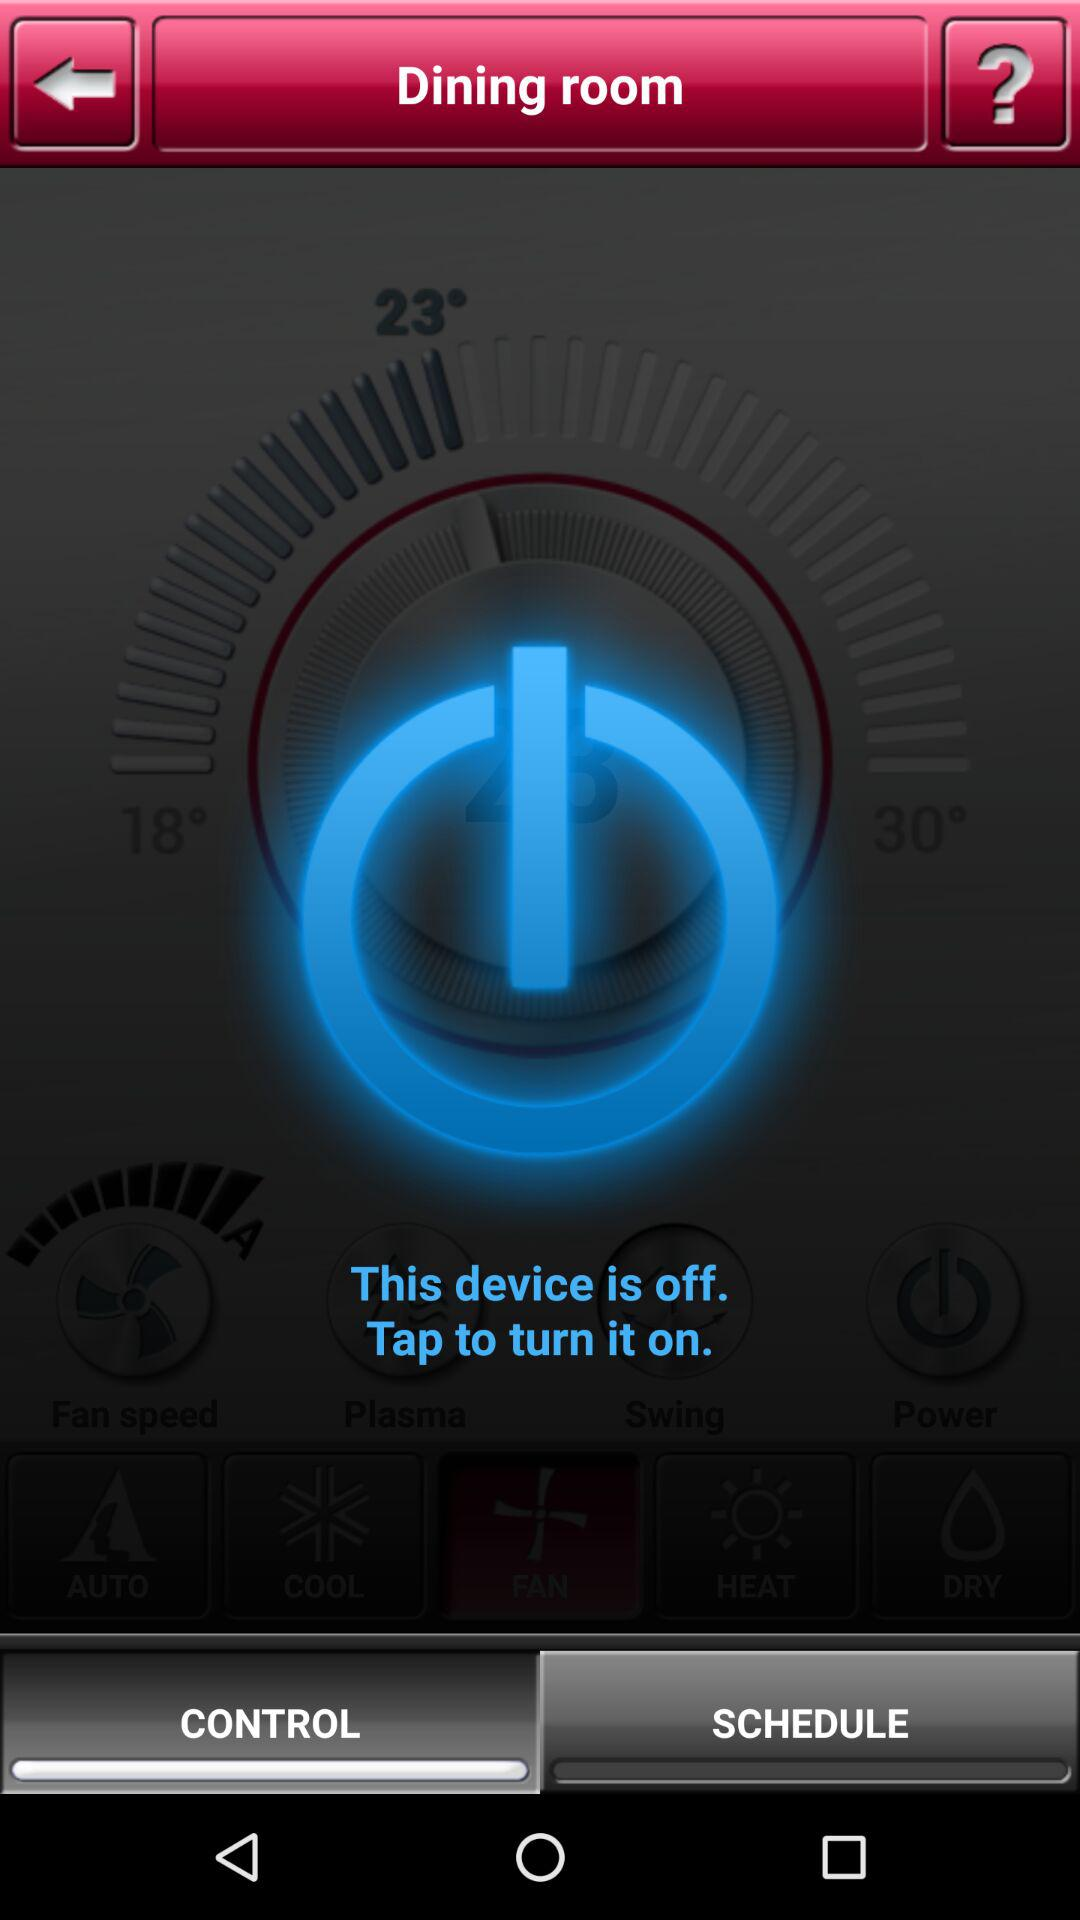Which tab is selected? The selected tab is "CONTROL". 